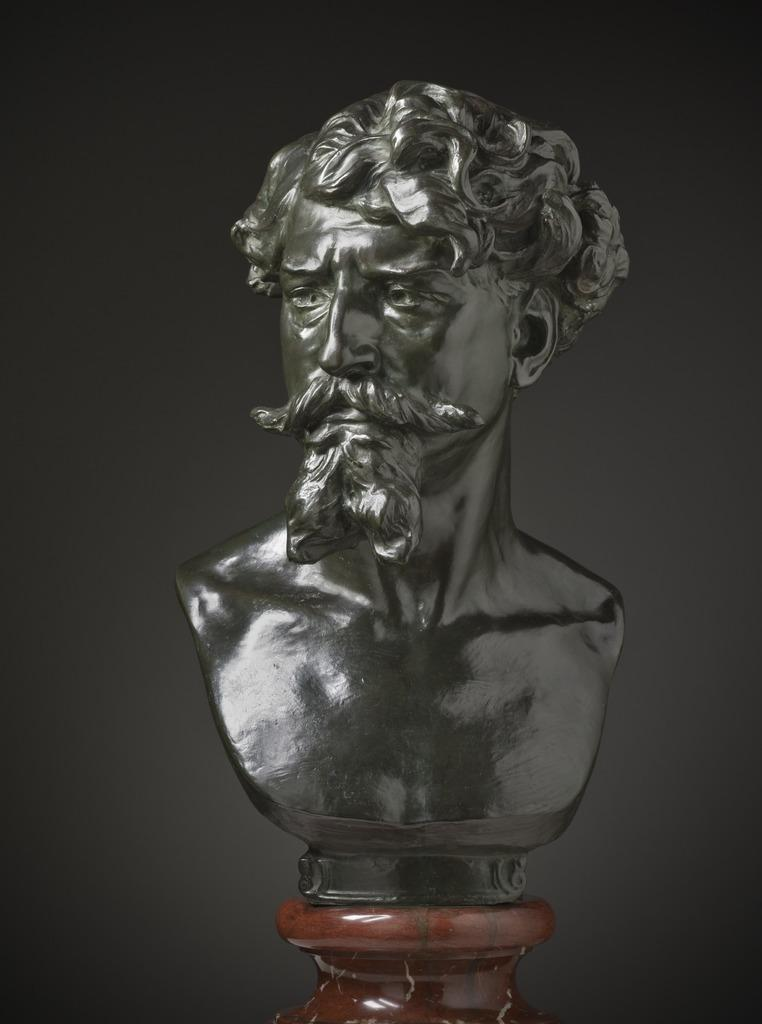What is the main subject of the image? The main subject of the image is a portrait of a man. What is the portrait placed on? The portrait is placed on a brown object, which resembles a pot. What color is the background of the image? The background of the image is black in color. What type of silk fabric is draped over the man's shoulders in the portrait? There is no silk fabric or any fabric draped over the man's shoulders in the portrait; he is depicted wearing a shirt. 